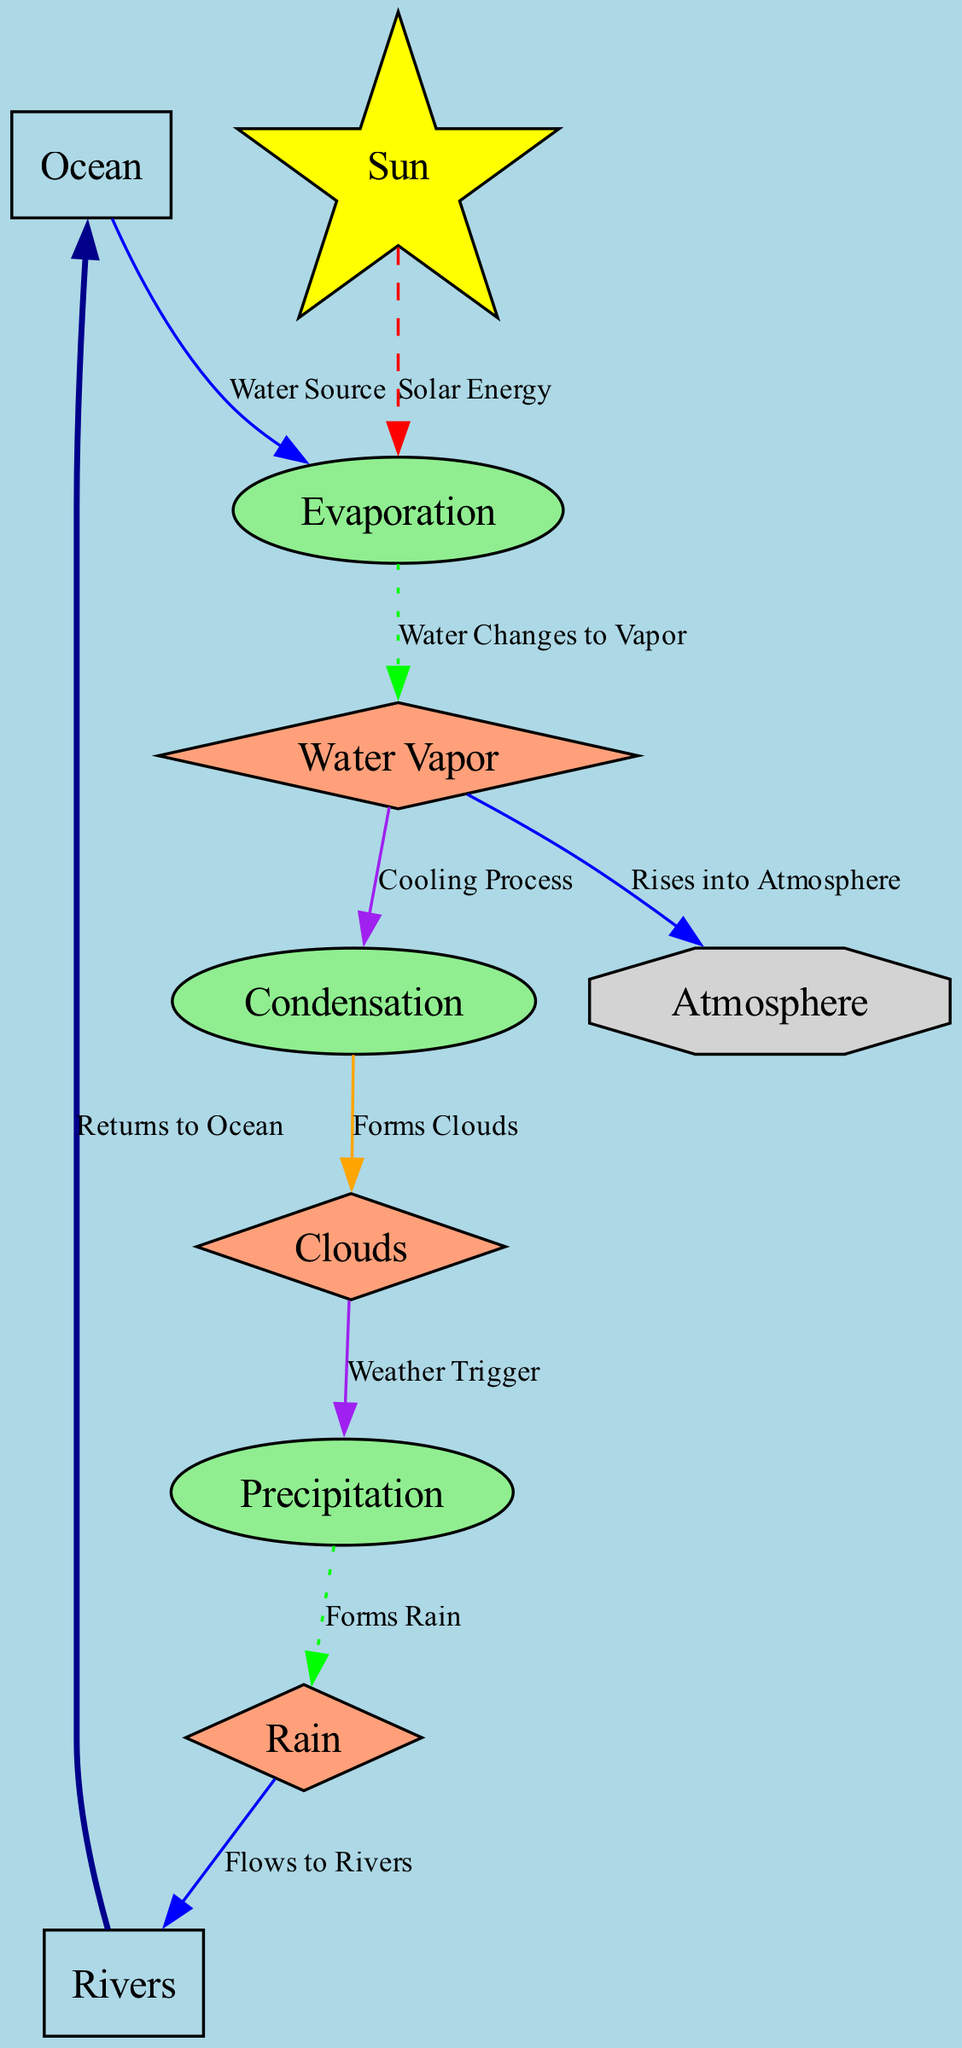What is the main source of water in the water cycle? The diagram labels the ocean as a "Water Source," indicating it is the origin of water for the cycle.
Answer: Ocean How many processes are illustrated in the diagram? The diagram lists three processes: Evaporation, Condensation, and Precipitation, totaling three processes.
Answer: 3 What transformation occurs after evaporation? The diagram shows that after evaporation, water changes to vapor, clearly stating this transformation directly.
Answer: Water Vapor Which energy source is involved in the evaporation process? The diagram indicates that solar energy from the sun drives the evaporation process, specifying the energy source contributing to it.
Answer: Sun What do clouds form from? The diagram directly states that clouds form from condensation, indicating that the process of condensation is responsible for cloud formation.
Answer: Condensation What happens to rain after it falls? The diagram illustrates that rain flows to rivers, detailing the next step in the water cycle following precipitation.
Answer: Flows to Rivers How does water vapor rise into the atmosphere? The diagram shows that water vapor rises into the atmosphere, indicating the flow from the water vapor node to the atmosphere node in the cycle.
Answer: Rises into Atmosphere What triggers precipitation in the diagram? The trigger for precipitation, as indicated in the diagram, is clouds interacting with the process shown before them, which is labeled as a weather trigger.
Answer: Weather Trigger What is the final destination of the water in the cycle? The diagram indicates that water ultimately returns to the ocean, completing the water cycle by flowing back to its starting point.
Answer: Returns to Ocean 